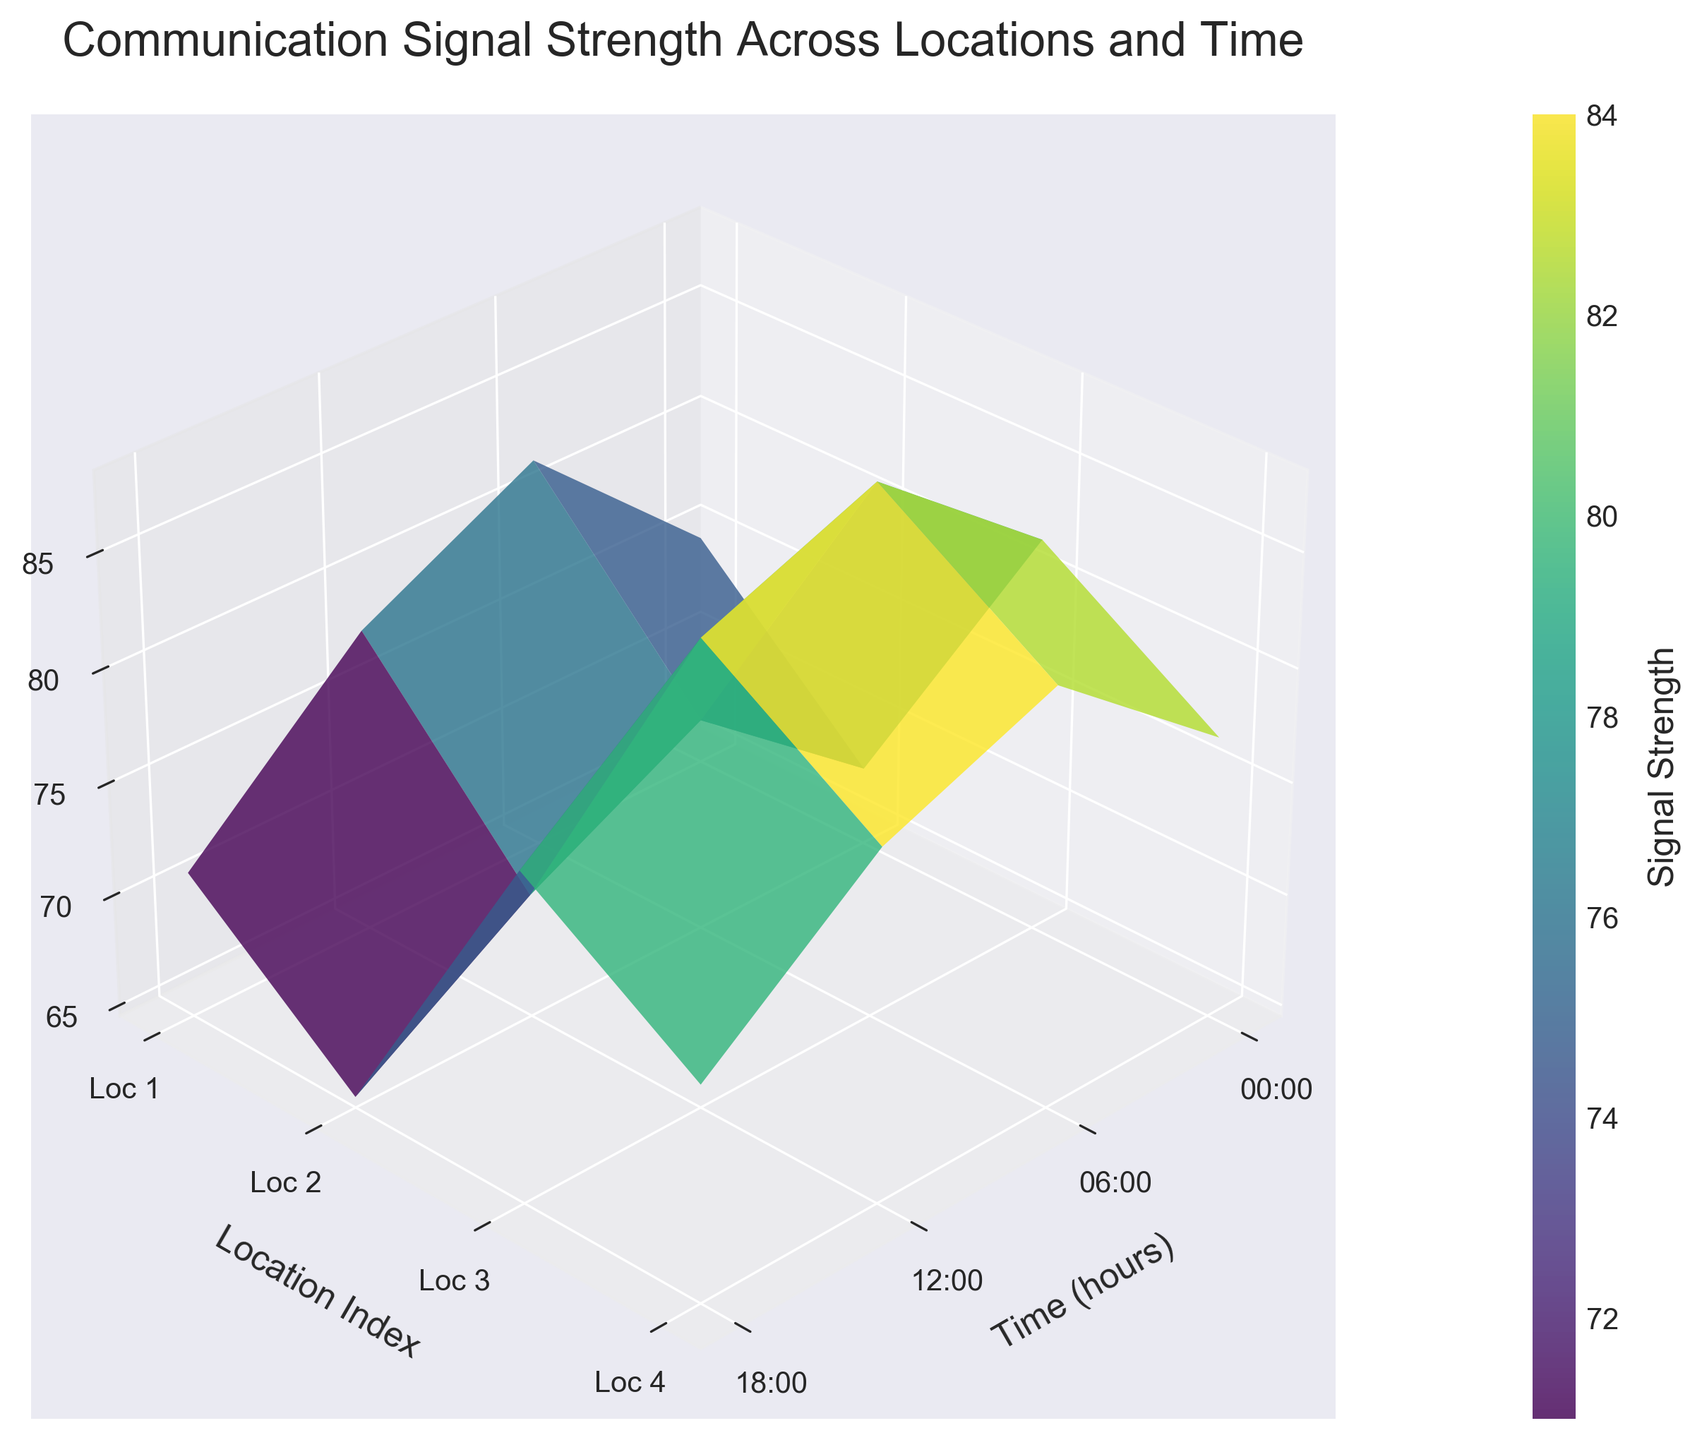What is the title of the figure? The title of the figure is shown at the top and provides a summary of what the plot represents. Here, it states, "Communication Signal Strength Across Locations and Time".
Answer: Communication Signal Strength Across Locations and Time Which time has the highest signal strength for Location 3? Look at the Z-axis values for Location 3 (the third index on the Y-axis). Track these values across the X-axis (time). The highest Z value is seen at 12:00.
Answer: 12:00 What is the general trend of the signal strength from 0:00 to 18:00? Observing the surface along the X-axis (time axis), the signal strength tends to either increase or remain stable as you move from left (0:00) to right (18:00). This denotes an overall increase or stability in signal strength over time during the day.
Answer: Increasing/Stabilizing trend Which location shows the highest average signal strength throughout the day? To find the average, add the signal strengths for each time point at each location and divide by 4. Location 3 has the signal strengths 82, 88, 85, and 79. The sum is 334, and the average is 334/4 = 83.5, which is the highest.
Answer: Location 3 How does the signal strength at 12:00 compare across different locations? Compare the Z-axis values at 12:00 (the third value on the X-axis) for all locations. For Location 1: 82, Location 2: 74, Location 3: 88, Location 4: 83. Location 3 has the highest signal strength at 12:00.
Answer: Location 3 Which location has the most uniform signal strength across the day? Uniformity can be assessed by observing the stability of the Z-axis values over time for each location. Location 4 (signal strengths 77, 83, 80, 74) shows less variance compared to others.
Answer: Location 4 Which two time points show the greatest difference in signal strength overall, and what is that difference? Compare differences between signal strengths at different time points across all locations. For example, for 12:00 and 0:00, sum all signal values: (82+74+88+83) - (71+65+79+74) = 327 - 289 = 38. This is the highest difference.
Answer: 12:00 and 0:00, 38 What is the signal strength at Location 2 at 18:00? Checking the specific point for Location 2 (second index on Y-axis) and 18:00 (fourth index on X-axis), the value is 70.
Answer: 70 Does any location experience a drop in signal strength at 18:00 compared to 12:00? Compare the signal strength values at 12:00 and 18:00 for each location. Location 2 (74 to 70) and Location 4 (83 to 80) experience drops.
Answer: Yes, Location 2 and Location 4 